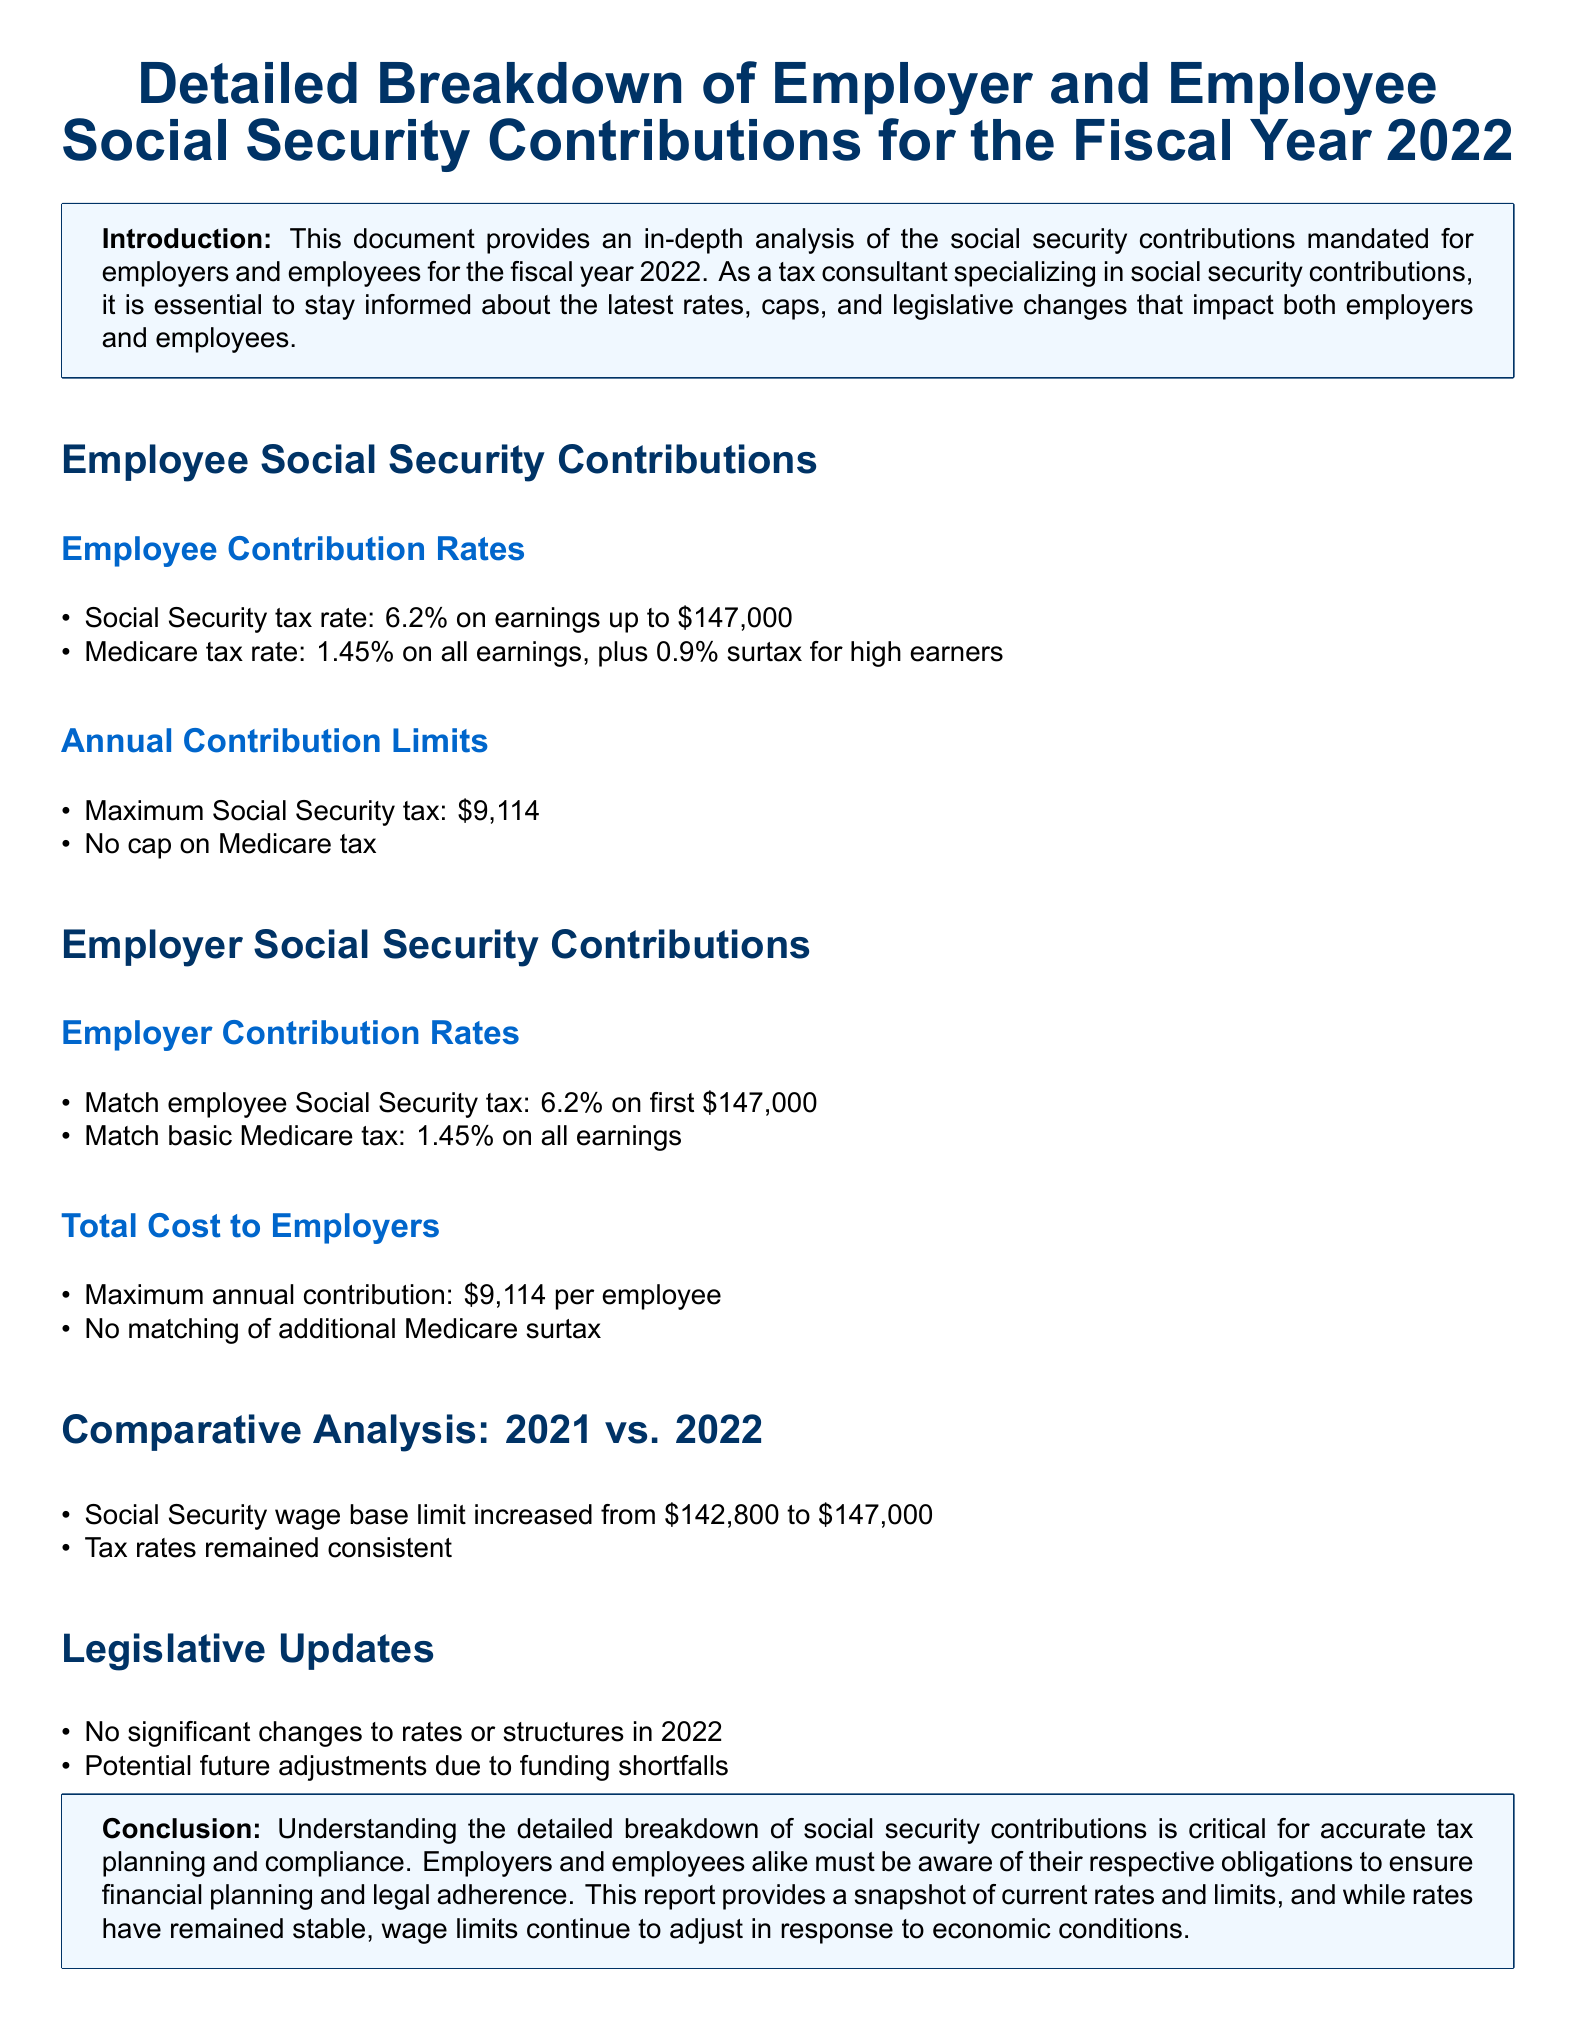What is the employee Social Security tax rate? The employee Social Security tax rate for the fiscal year 2022 is outlined in the document as 6.2%.
Answer: 6.2% What is the annual limit for the Social Security tax? The document specifies the maximum Social Security tax contribution limit as $9,114 for the year 2022.
Answer: $9,114 What is the Medicare tax rate for all earnings? According to the document, the Medicare tax rate for all earnings is 1.45%.
Answer: 1.45% What was the Social Security wage base limit in 2021? The document indicates that the Social Security wage base limit in 2021 was $142,800.
Answer: $142,800 What is the maximum annual contribution for employers? The document states that the maximum annual contribution for employers is $9,114 per employee.
Answer: $9,114 What significant change occurred in the wage base limit from 2021 to 2022? The document notes that the wage base limit increased from $142,800 to $147,000 between 2021 and 2022.
Answer: Increased What happened to the tax rates in 2022 compared to 2021? The document indicates that the tax rates remained consistent between 2021 and 2022.
Answer: Consistent Were there any significant legislative changes to rates or structures in 2022? The document states that there were no significant changes to rates or structures in 2022.
Answer: No What must employees and employers be aware of for accurate tax planning? The document emphasizes that both employers and employees must be aware of their respective obligations.
Answer: Obligations 